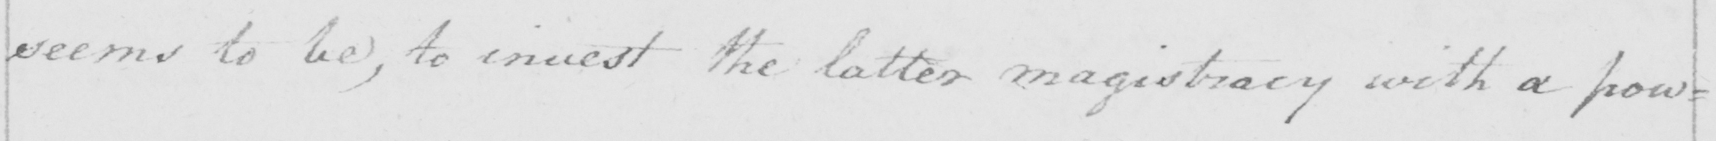What is written in this line of handwriting? seems to be  , to invest the latter magistracy with a pow= 